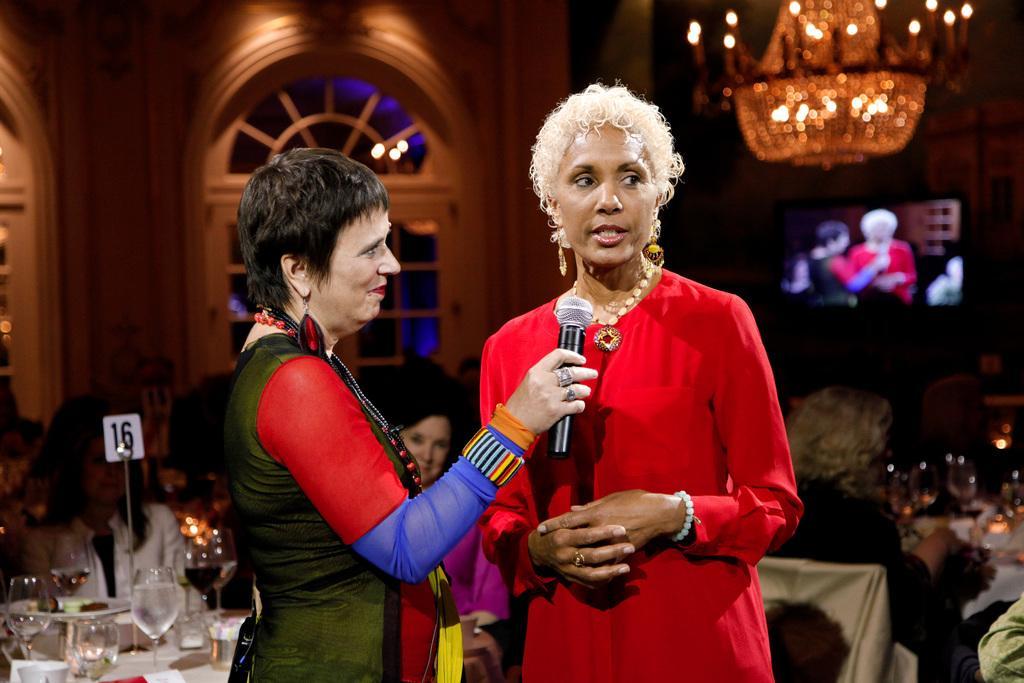How would you summarize this image in a sentence or two? In this image we can see few people sitting on the chairs and two of them are standing, a person is holding a mic, there are few glasses with drink, a board and few objects on the table and in the background there is a screen, chandelier and a door to the wall. 